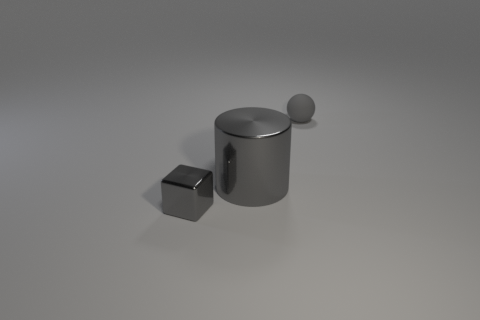Add 3 small matte things. How many objects exist? 6 Subtract all balls. How many objects are left? 2 Subtract all small gray balls. Subtract all gray metal things. How many objects are left? 0 Add 3 big metallic objects. How many big metallic objects are left? 4 Add 1 blue metallic spheres. How many blue metallic spheres exist? 1 Subtract 1 gray cylinders. How many objects are left? 2 